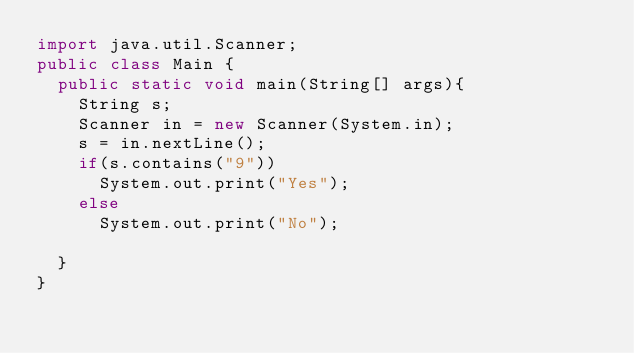Convert code to text. <code><loc_0><loc_0><loc_500><loc_500><_Java_>import java.util.Scanner;
public class Main {
	public static void main(String[] args){
		String s;
		Scanner in = new Scanner(System.in);
		s = in.nextLine();
		if(s.contains("9"))
			System.out.print("Yes");
		else
			System.out.print("No");
		
	}
}
</code> 